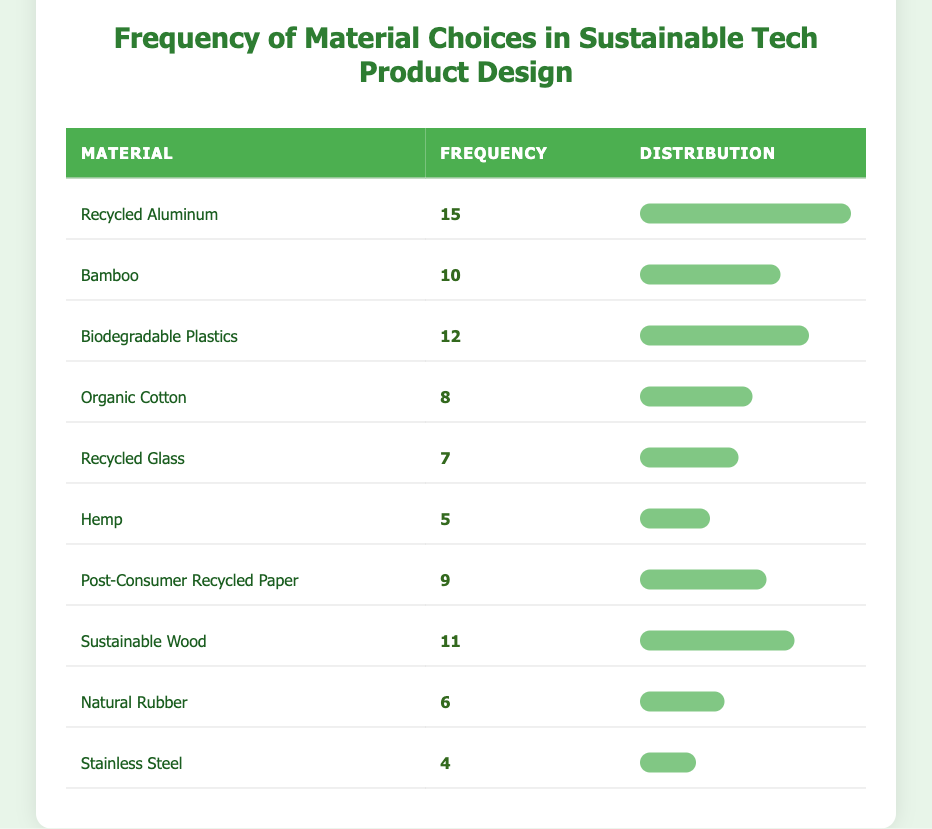What material has the highest frequency of use? By looking at the "Frequency" column, the material with the highest frequency is "Recycled Aluminum," which has a frequency of 15.
Answer: Recycled Aluminum Which two materials have frequencies that add up to 22? The two materials "Bamboo" (frequency 10) and "Biodegradable Plastics" (frequency 12) can be added together: 10 + 12 = 22.
Answer: Bamboo and Biodegradable Plastics Is "Natural Rubber" more frequently chosen than "Stainless Steel"? The frequency for "Natural Rubber" is 6, while for "Stainless Steel" it is 4. Since 6 is greater than 4, it is true that "Natural Rubber" is chosen more frequently.
Answer: Yes What is the average frequency of the materials listed? To find the average, we first sum all the frequencies: 15 + 10 + 12 + 8 + 7 + 5 + 9 + 11 + 6 + 4 = 87. There are 10 materials, so the average is 87/10 = 8.7.
Answer: 8.7 Which material has a frequency that is below the median frequency of all materials? The frequencies are sorted as follows: 4, 5, 6, 7, 8, 9, 10, 11, 12, 15. The median is the average of the 5th and 6th numbers in this series (8 and 9), which equals 8.5. Thus, materials with frequencies below 8.5 include "Stainless Steel," "Hemp," "Natural Rubber," and "Recycled Glass."
Answer: Stainless Steel, Hemp, Natural Rubber, Recycled Glass 